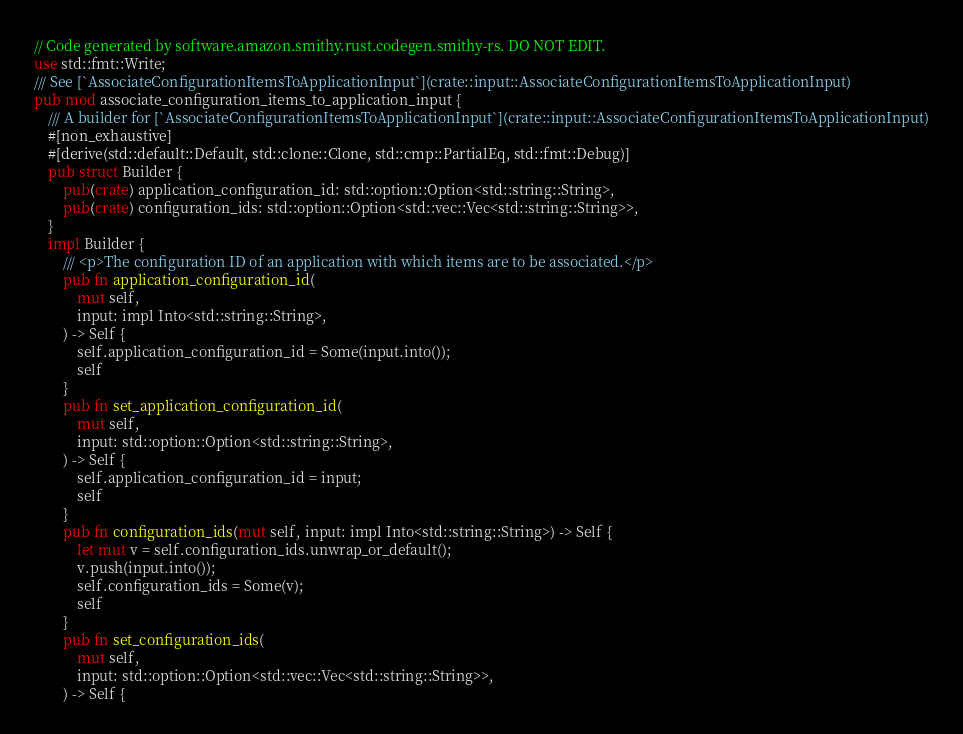Convert code to text. <code><loc_0><loc_0><loc_500><loc_500><_Rust_>// Code generated by software.amazon.smithy.rust.codegen.smithy-rs. DO NOT EDIT.
use std::fmt::Write;
/// See [`AssociateConfigurationItemsToApplicationInput`](crate::input::AssociateConfigurationItemsToApplicationInput)
pub mod associate_configuration_items_to_application_input {
    /// A builder for [`AssociateConfigurationItemsToApplicationInput`](crate::input::AssociateConfigurationItemsToApplicationInput)
    #[non_exhaustive]
    #[derive(std::default::Default, std::clone::Clone, std::cmp::PartialEq, std::fmt::Debug)]
    pub struct Builder {
        pub(crate) application_configuration_id: std::option::Option<std::string::String>,
        pub(crate) configuration_ids: std::option::Option<std::vec::Vec<std::string::String>>,
    }
    impl Builder {
        /// <p>The configuration ID of an application with which items are to be associated.</p>
        pub fn application_configuration_id(
            mut self,
            input: impl Into<std::string::String>,
        ) -> Self {
            self.application_configuration_id = Some(input.into());
            self
        }
        pub fn set_application_configuration_id(
            mut self,
            input: std::option::Option<std::string::String>,
        ) -> Self {
            self.application_configuration_id = input;
            self
        }
        pub fn configuration_ids(mut self, input: impl Into<std::string::String>) -> Self {
            let mut v = self.configuration_ids.unwrap_or_default();
            v.push(input.into());
            self.configuration_ids = Some(v);
            self
        }
        pub fn set_configuration_ids(
            mut self,
            input: std::option::Option<std::vec::Vec<std::string::String>>,
        ) -> Self {</code> 